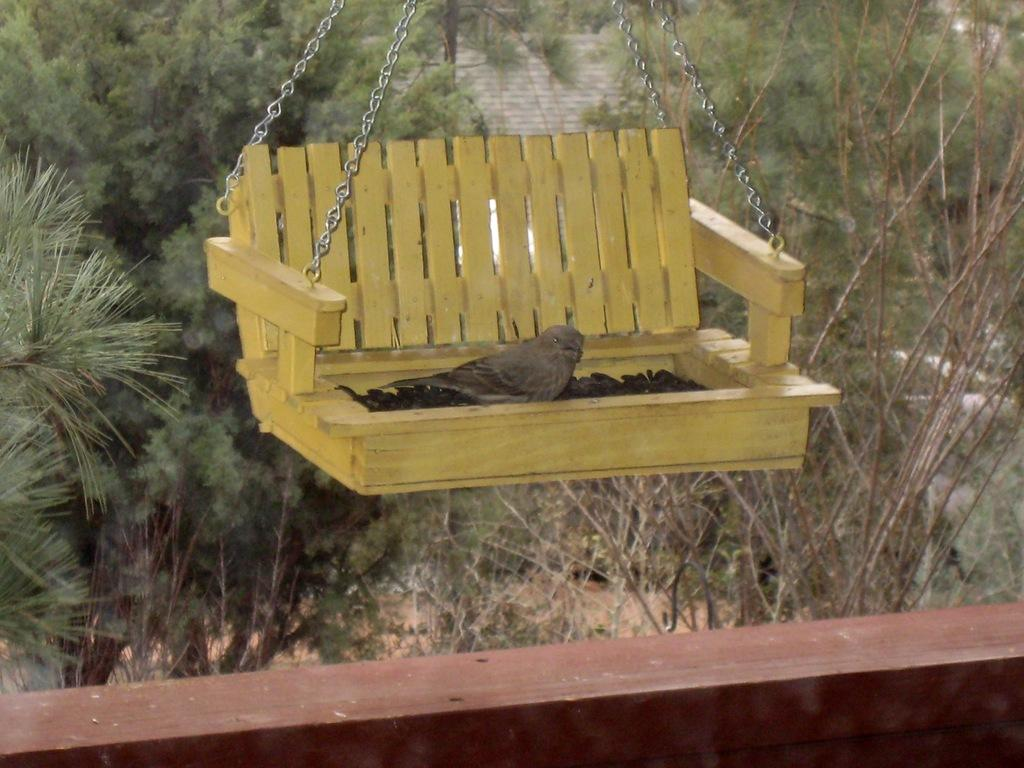What is the main subject in the foreground of the picture? There is a bird in the foreground of the picture. What is the bird's position in the image? The bird is in a cradle. What can be seen in the background of the image? There are trees and a building roof top visible in the background. What type of club can be seen in the bird's hand in the image? There is no club present in the image, and the bird does not have hands. 